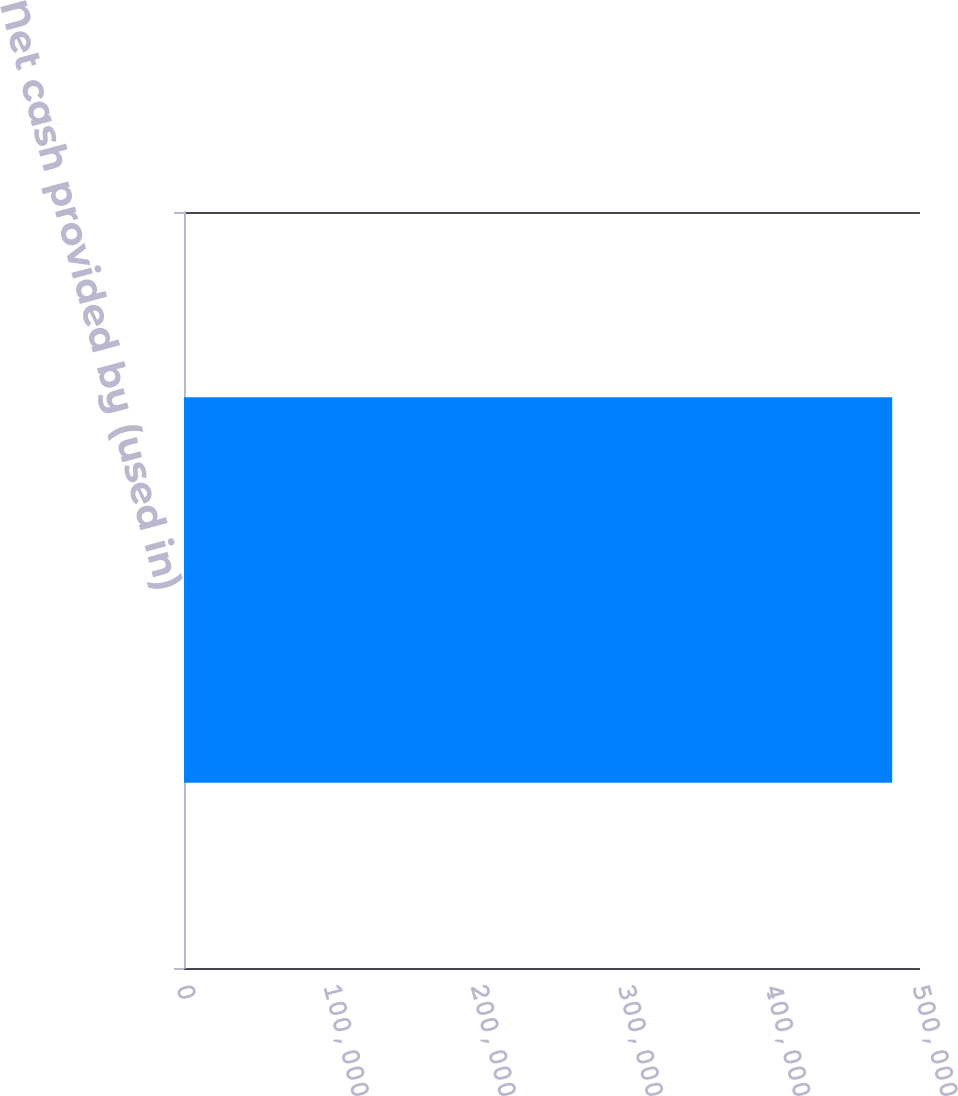<chart> <loc_0><loc_0><loc_500><loc_500><bar_chart><fcel>Net cash provided by (used in)<nl><fcel>481118<nl></chart> 